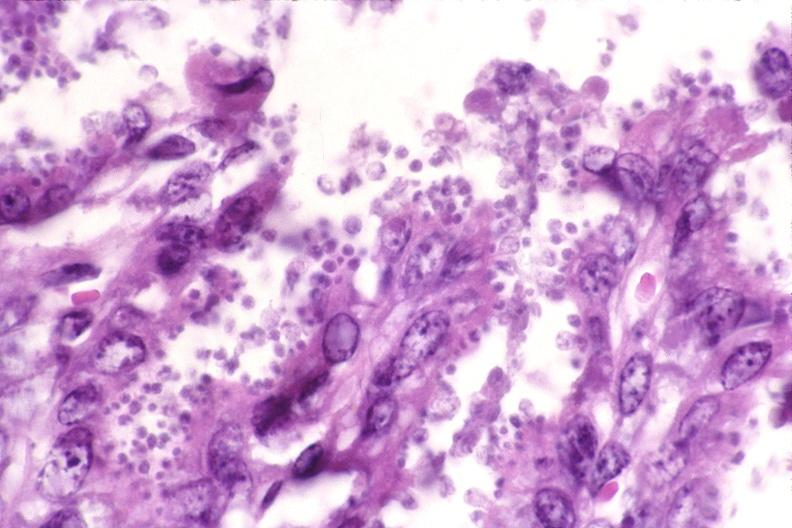s notochord present?
Answer the question using a single word or phrase. No 